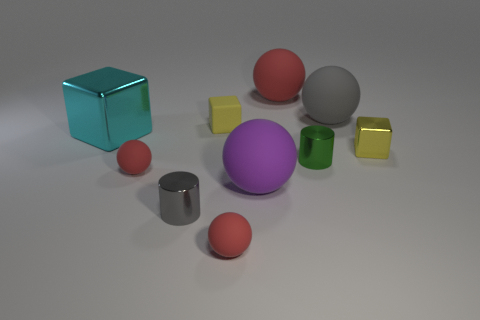How many red spheres must be subtracted to get 1 red spheres? 2 Subtract all yellow blocks. How many blocks are left? 1 Subtract all blocks. How many objects are left? 7 Subtract all cyan cubes. How many cubes are left? 2 Subtract 1 spheres. How many spheres are left? 4 Subtract 0 cyan balls. How many objects are left? 10 Subtract all red cylinders. Subtract all red cubes. How many cylinders are left? 2 Subtract all cyan blocks. How many purple spheres are left? 1 Subtract all small yellow metal cubes. Subtract all tiny gray things. How many objects are left? 8 Add 3 tiny green metallic cylinders. How many tiny green metallic cylinders are left? 4 